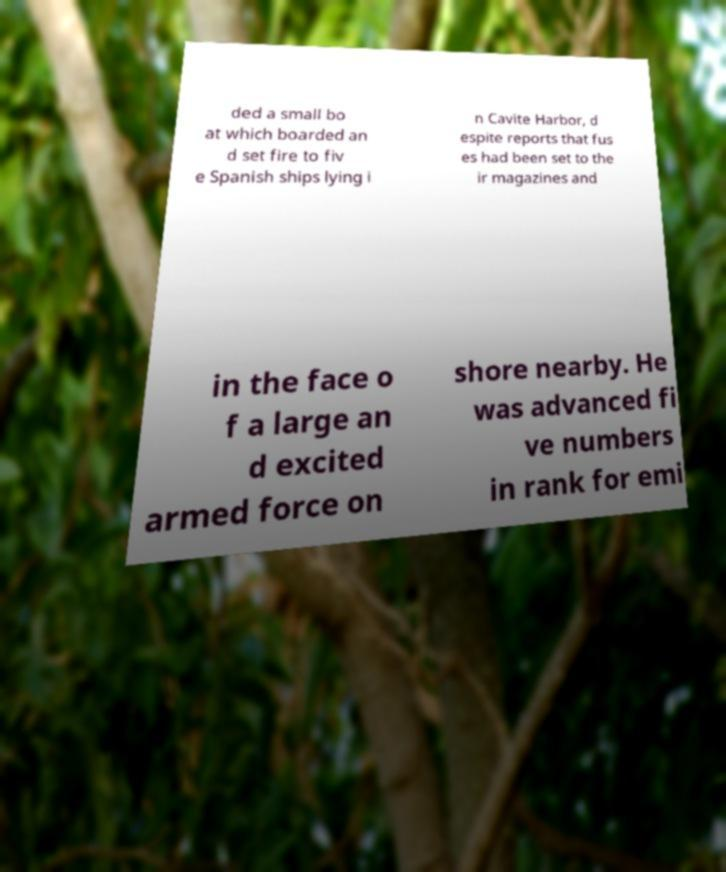Can you accurately transcribe the text from the provided image for me? ded a small bo at which boarded an d set fire to fiv e Spanish ships lying i n Cavite Harbor, d espite reports that fus es had been set to the ir magazines and in the face o f a large an d excited armed force on shore nearby. He was advanced fi ve numbers in rank for emi 